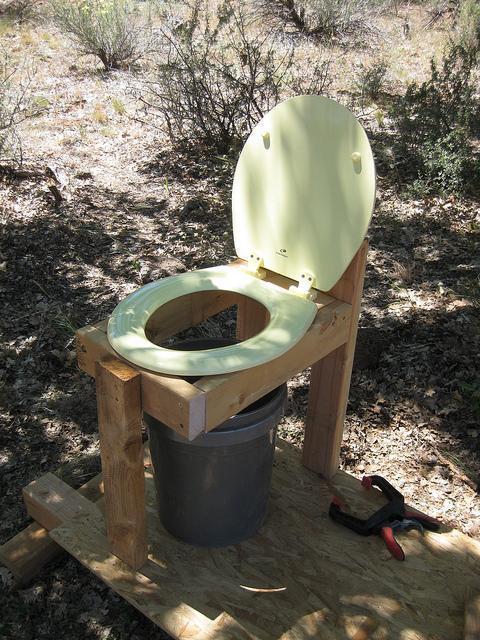How many boats do you see?
Give a very brief answer. 0. 